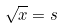<formula> <loc_0><loc_0><loc_500><loc_500>\sqrt { x } = s</formula> 